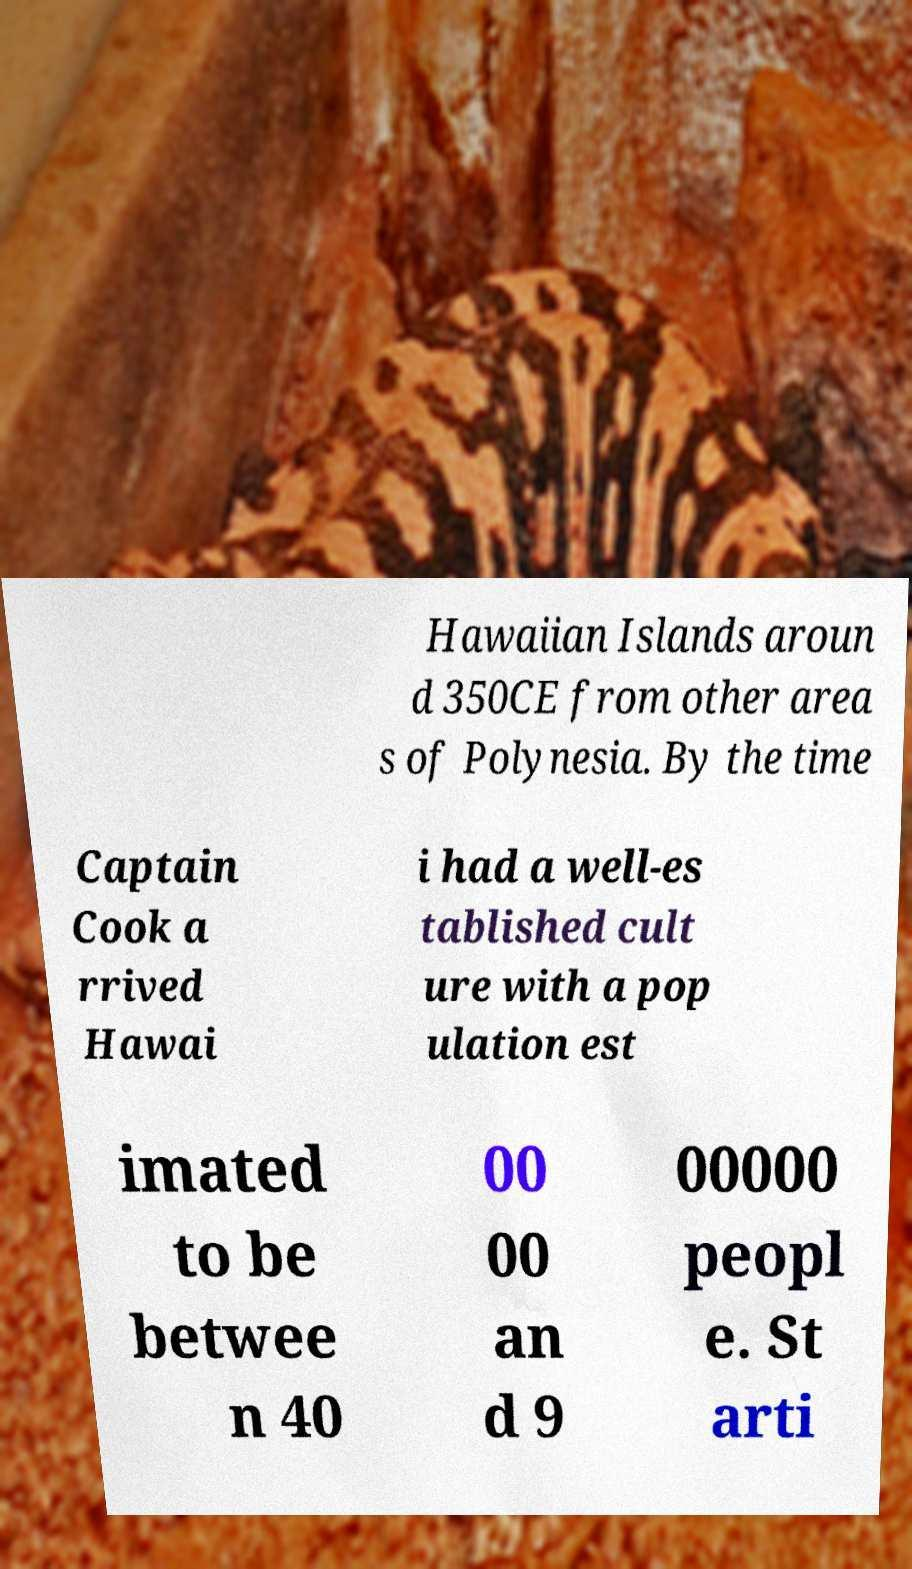Can you read and provide the text displayed in the image?This photo seems to have some interesting text. Can you extract and type it out for me? Hawaiian Islands aroun d 350CE from other area s of Polynesia. By the time Captain Cook a rrived Hawai i had a well-es tablished cult ure with a pop ulation est imated to be betwee n 40 00 00 an d 9 00000 peopl e. St arti 